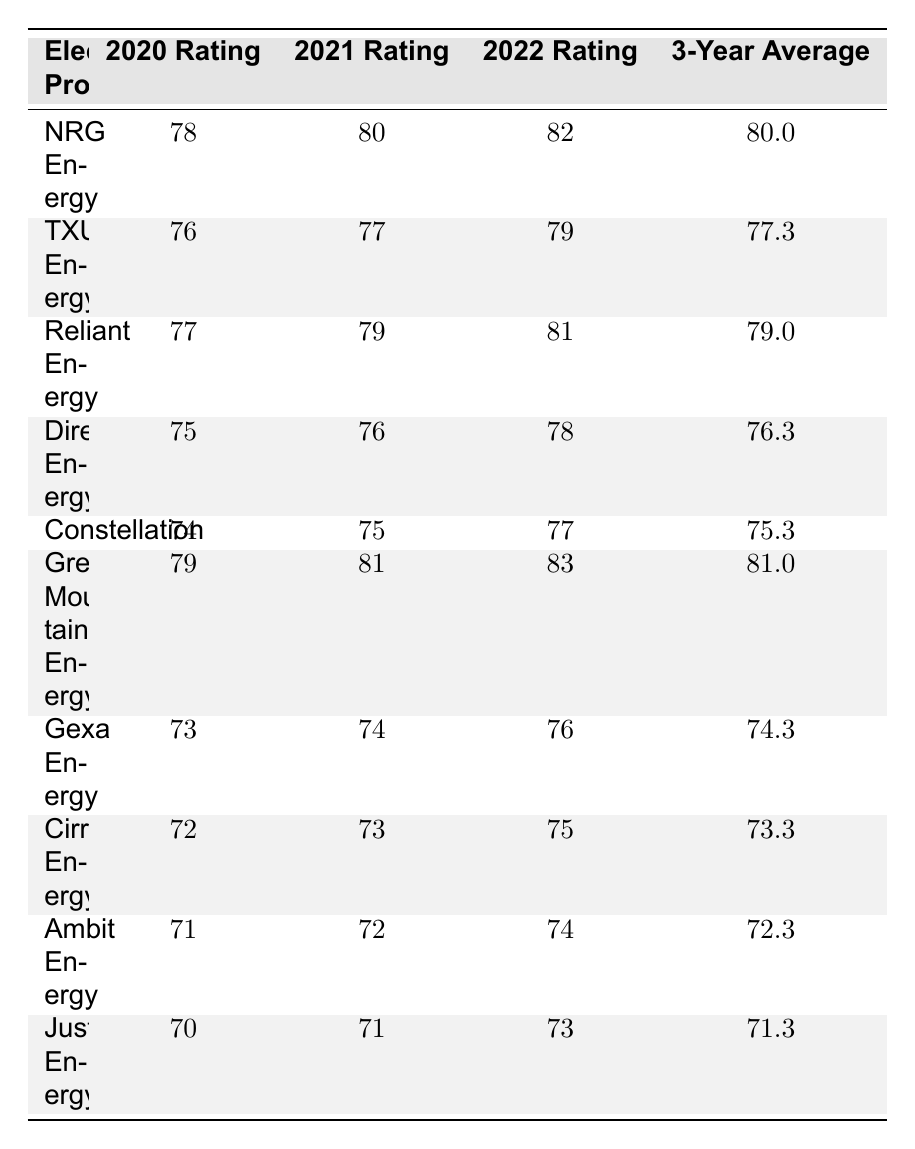What was the highest customer satisfaction rating in 2022? By looking at the 2022 Ratings column, Green Mountain Energy has the highest rating of 83.
Answer: 83 Which electricity provider had the lowest 3-year average rating? The 3-Year Average ratings are compared, and Just Energy has the lowest average at 71.3.
Answer: Just Energy What was the average rating for TXU Energy across the three years? By adding 76, 77, and 79 together (76 + 77 + 79 = 232) and dividing by 3, the average is 232 / 3 = 77.3.
Answer: 77.3 Is NRG Energy's average rating higher than Reliant Energy's? NRG Energy's average rating is 80.0 while Reliant Energy's is 79.0, so yes, NRG Energy's is higher.
Answer: Yes What is the difference between the highest and lowest rating in 2021? The highest rating in 2021 is Green Mountain Energy with 81, and the lowest is Just Energy with 71. The difference is 81 - 71 = 10.
Answer: 10 How many providers had ratings above 75 in 2020? Looking at the 2020 Rating column, the providers with ratings above 75 are NRG Energy, TXU Energy, Reliant Energy, Direct Energy, Green Mountain Energy, and Constellation. There are 6 providers.
Answer: 6 Which provider improved their rating the most from 2020 to 2022? By calculating the differences, Green Mountain Energy improved from 79 to 83 (+4), Reliant Energy from 77 to 81 (+4), and NRG Energy from 78 to 82 (+4). Since they all improved by the same amount, they are tied for the most improvement.
Answer: Tied (NRG Energy, Reliant Energy, Green Mountain Energy) What percentage of providers had an average rating above 75? Out of 10 providers, 6 had an average rating above 75 (NRG Energy, Reliant Energy, Green Mountain Energy, all with averages over 75). The percentage is (6/10) * 100 = 60%.
Answer: 60% Which provider had a 2021 rating less than 78 and had the lowest rating in 2020? Cirro Energy and Just Energy both had 2021 ratings less than 78, but Just Energy had the lowest 2020 rating of 70.
Answer: Just Energy Did any provider have the same rating in consecutive years? Yes, Gexa Energy had the same rating of 74 in both 2021 and 2022.
Answer: Yes 